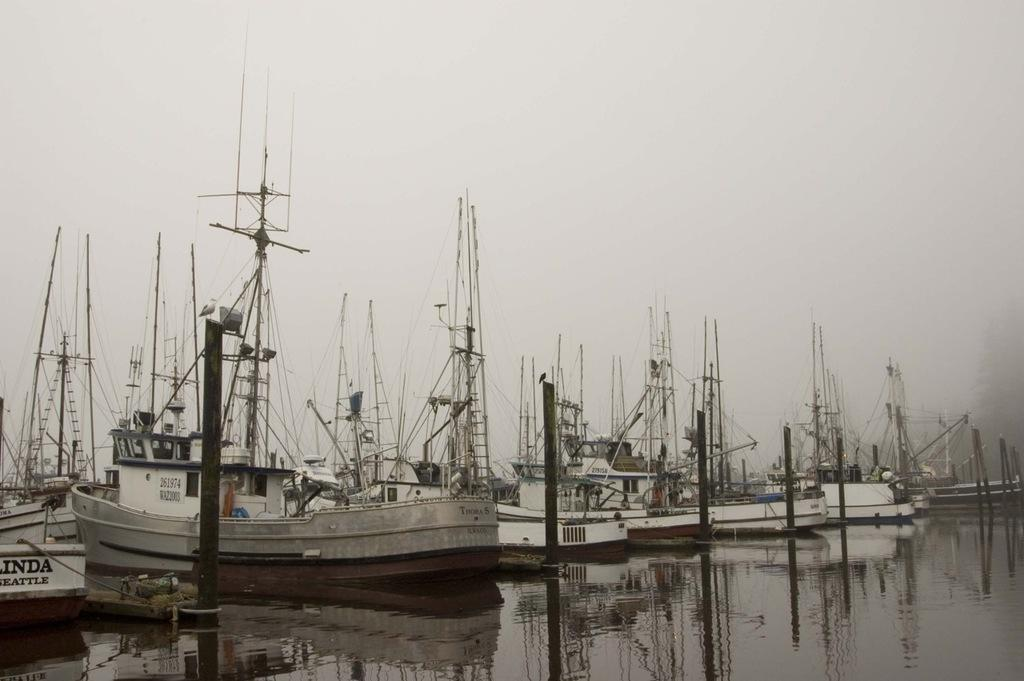<image>
Give a short and clear explanation of the subsequent image. A boat sits at a dock in the water with the number 261974 visible. 